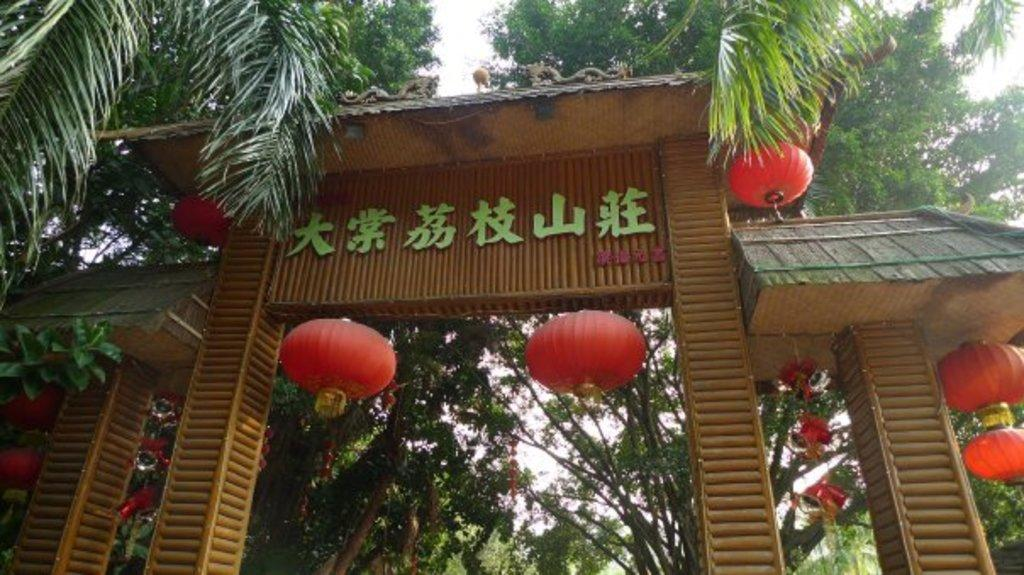What structure is present in the image? There is an arch in the image. What feature is added to the arch? The arch has lights on it. What can be seen in the background of the image? There is a group of trees and the sky visible in the background. How many servants are standing near the arch in the image? There are no servants present in the image. What statement is being made by the arch in the image? The arch is a structure and does not make statements. 